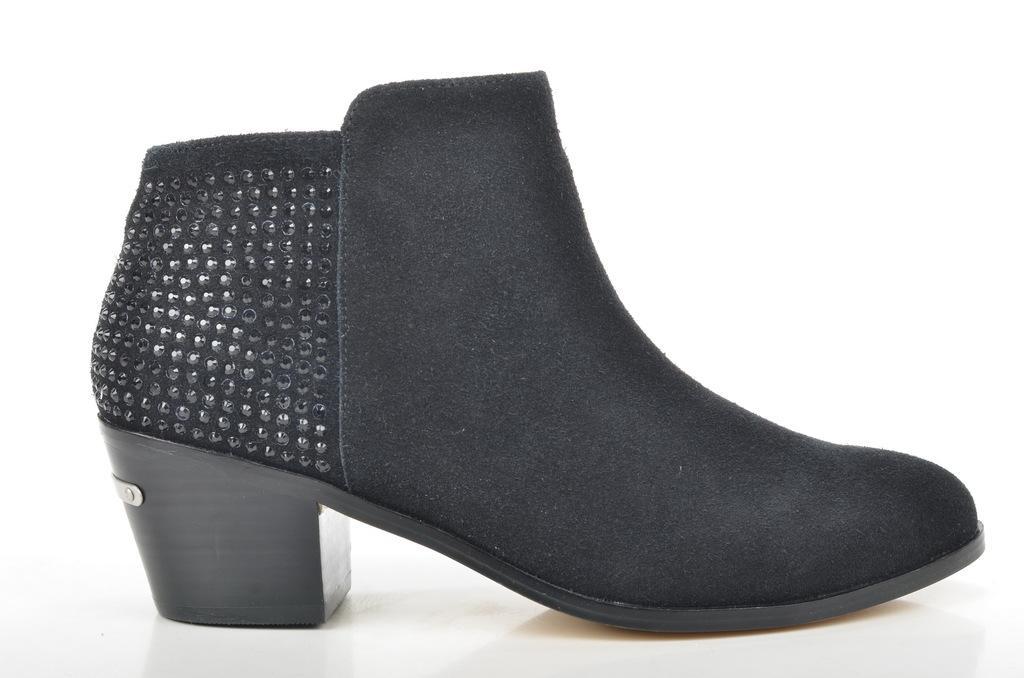In one or two sentences, can you explain what this image depicts? In this picture I can see a footwear. 